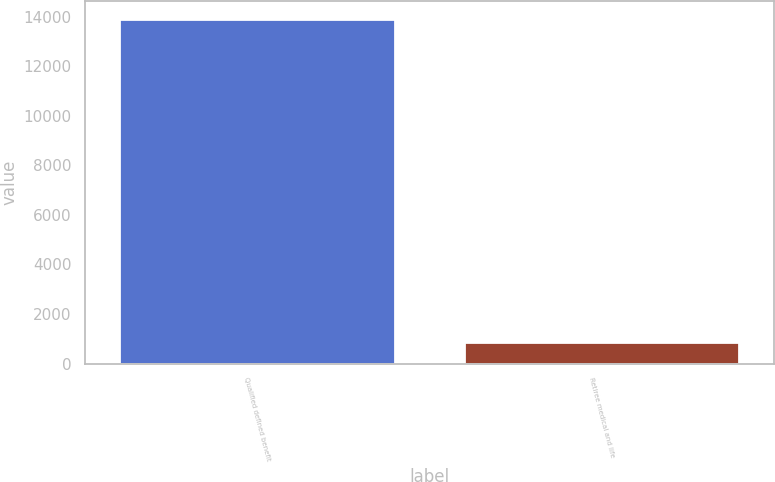Convert chart to OTSL. <chart><loc_0><loc_0><loc_500><loc_500><bar_chart><fcel>Qualified defined benefit<fcel>Retiree medical and life<nl><fcel>13920<fcel>870<nl></chart> 